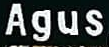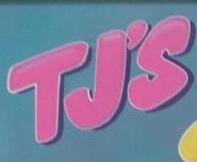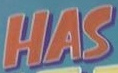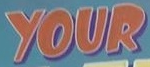What words can you see in these images in sequence, separated by a semicolon? Agus; TJ'S; HAS; YOUR 